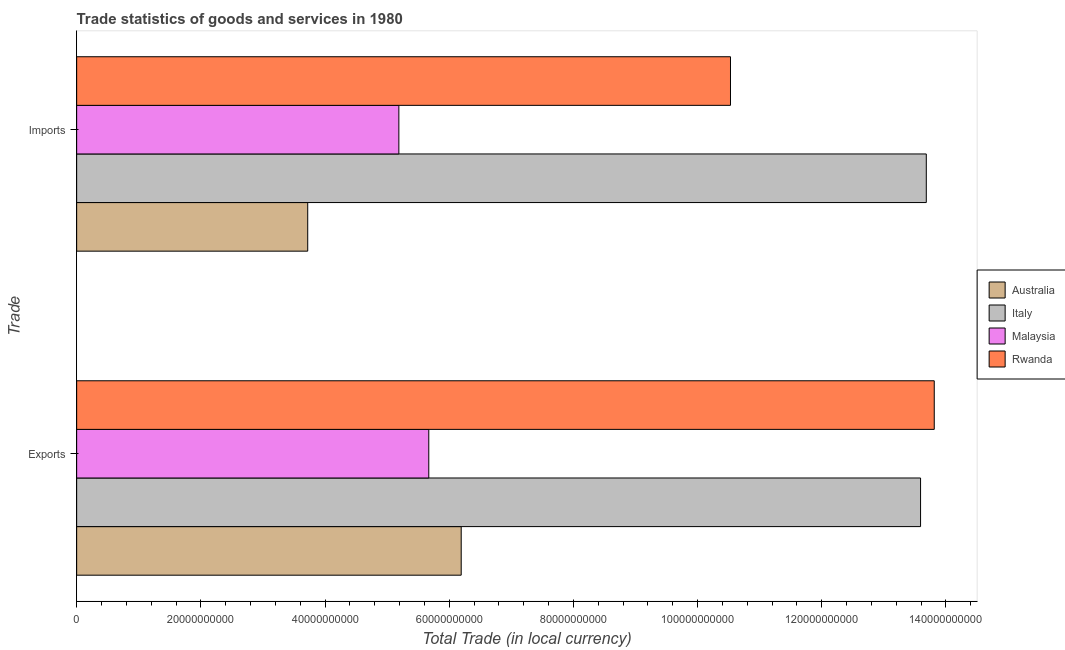How many different coloured bars are there?
Provide a short and direct response. 4. How many groups of bars are there?
Keep it short and to the point. 2. Are the number of bars per tick equal to the number of legend labels?
Offer a terse response. Yes. How many bars are there on the 1st tick from the top?
Keep it short and to the point. 4. How many bars are there on the 1st tick from the bottom?
Offer a terse response. 4. What is the label of the 2nd group of bars from the top?
Your response must be concise. Exports. What is the export of goods and services in Malaysia?
Give a very brief answer. 5.67e+1. Across all countries, what is the maximum imports of goods and services?
Your answer should be compact. 1.37e+11. Across all countries, what is the minimum export of goods and services?
Your answer should be compact. 5.67e+1. What is the total export of goods and services in the graph?
Give a very brief answer. 3.93e+11. What is the difference between the export of goods and services in Australia and that in Italy?
Ensure brevity in your answer.  -7.40e+1. What is the difference between the imports of goods and services in Australia and the export of goods and services in Malaysia?
Ensure brevity in your answer.  -1.95e+1. What is the average imports of goods and services per country?
Your response must be concise. 8.28e+1. What is the difference between the export of goods and services and imports of goods and services in Italy?
Keep it short and to the point. -9.24e+08. What is the ratio of the export of goods and services in Malaysia to that in Australia?
Offer a very short reply. 0.92. Is the export of goods and services in Australia less than that in Rwanda?
Keep it short and to the point. Yes. What does the 2nd bar from the top in Exports represents?
Your response must be concise. Malaysia. Are all the bars in the graph horizontal?
Offer a terse response. Yes. What is the difference between two consecutive major ticks on the X-axis?
Offer a very short reply. 2.00e+1. What is the title of the graph?
Your response must be concise. Trade statistics of goods and services in 1980. Does "Puerto Rico" appear as one of the legend labels in the graph?
Ensure brevity in your answer.  No. What is the label or title of the X-axis?
Provide a succinct answer. Total Trade (in local currency). What is the label or title of the Y-axis?
Your response must be concise. Trade. What is the Total Trade (in local currency) in Australia in Exports?
Give a very brief answer. 6.19e+1. What is the Total Trade (in local currency) in Italy in Exports?
Provide a succinct answer. 1.36e+11. What is the Total Trade (in local currency) of Malaysia in Exports?
Offer a terse response. 5.67e+1. What is the Total Trade (in local currency) in Rwanda in Exports?
Ensure brevity in your answer.  1.38e+11. What is the Total Trade (in local currency) in Australia in Imports?
Your answer should be compact. 3.72e+1. What is the Total Trade (in local currency) in Italy in Imports?
Your response must be concise. 1.37e+11. What is the Total Trade (in local currency) in Malaysia in Imports?
Your response must be concise. 5.19e+1. What is the Total Trade (in local currency) of Rwanda in Imports?
Provide a short and direct response. 1.05e+11. Across all Trade, what is the maximum Total Trade (in local currency) of Australia?
Provide a succinct answer. 6.19e+1. Across all Trade, what is the maximum Total Trade (in local currency) of Italy?
Your response must be concise. 1.37e+11. Across all Trade, what is the maximum Total Trade (in local currency) of Malaysia?
Provide a short and direct response. 5.67e+1. Across all Trade, what is the maximum Total Trade (in local currency) in Rwanda?
Make the answer very short. 1.38e+11. Across all Trade, what is the minimum Total Trade (in local currency) in Australia?
Your response must be concise. 3.72e+1. Across all Trade, what is the minimum Total Trade (in local currency) in Italy?
Your answer should be very brief. 1.36e+11. Across all Trade, what is the minimum Total Trade (in local currency) in Malaysia?
Your answer should be very brief. 5.19e+1. Across all Trade, what is the minimum Total Trade (in local currency) of Rwanda?
Give a very brief answer. 1.05e+11. What is the total Total Trade (in local currency) in Australia in the graph?
Offer a very short reply. 9.92e+1. What is the total Total Trade (in local currency) in Italy in the graph?
Your answer should be very brief. 2.73e+11. What is the total Total Trade (in local currency) in Malaysia in the graph?
Your answer should be very brief. 1.09e+11. What is the total Total Trade (in local currency) in Rwanda in the graph?
Ensure brevity in your answer.  2.43e+11. What is the difference between the Total Trade (in local currency) in Australia in Exports and that in Imports?
Keep it short and to the point. 2.47e+1. What is the difference between the Total Trade (in local currency) of Italy in Exports and that in Imports?
Provide a short and direct response. -9.24e+08. What is the difference between the Total Trade (in local currency) in Malaysia in Exports and that in Imports?
Give a very brief answer. 4.82e+09. What is the difference between the Total Trade (in local currency) in Rwanda in Exports and that in Imports?
Provide a succinct answer. 3.28e+1. What is the difference between the Total Trade (in local currency) in Australia in Exports and the Total Trade (in local currency) in Italy in Imports?
Keep it short and to the point. -7.49e+1. What is the difference between the Total Trade (in local currency) of Australia in Exports and the Total Trade (in local currency) of Malaysia in Imports?
Give a very brief answer. 1.00e+1. What is the difference between the Total Trade (in local currency) in Australia in Exports and the Total Trade (in local currency) in Rwanda in Imports?
Give a very brief answer. -4.34e+1. What is the difference between the Total Trade (in local currency) in Italy in Exports and the Total Trade (in local currency) in Malaysia in Imports?
Give a very brief answer. 8.40e+1. What is the difference between the Total Trade (in local currency) of Italy in Exports and the Total Trade (in local currency) of Rwanda in Imports?
Your answer should be compact. 3.06e+1. What is the difference between the Total Trade (in local currency) of Malaysia in Exports and the Total Trade (in local currency) of Rwanda in Imports?
Make the answer very short. -4.86e+1. What is the average Total Trade (in local currency) of Australia per Trade?
Your response must be concise. 4.96e+1. What is the average Total Trade (in local currency) in Italy per Trade?
Give a very brief answer. 1.36e+11. What is the average Total Trade (in local currency) in Malaysia per Trade?
Ensure brevity in your answer.  5.43e+1. What is the average Total Trade (in local currency) in Rwanda per Trade?
Provide a succinct answer. 1.22e+11. What is the difference between the Total Trade (in local currency) of Australia and Total Trade (in local currency) of Italy in Exports?
Give a very brief answer. -7.40e+1. What is the difference between the Total Trade (in local currency) in Australia and Total Trade (in local currency) in Malaysia in Exports?
Your response must be concise. 5.22e+09. What is the difference between the Total Trade (in local currency) of Australia and Total Trade (in local currency) of Rwanda in Exports?
Your answer should be compact. -7.62e+1. What is the difference between the Total Trade (in local currency) of Italy and Total Trade (in local currency) of Malaysia in Exports?
Give a very brief answer. 7.92e+1. What is the difference between the Total Trade (in local currency) of Italy and Total Trade (in local currency) of Rwanda in Exports?
Offer a terse response. -2.20e+09. What is the difference between the Total Trade (in local currency) of Malaysia and Total Trade (in local currency) of Rwanda in Exports?
Provide a short and direct response. -8.14e+1. What is the difference between the Total Trade (in local currency) of Australia and Total Trade (in local currency) of Italy in Imports?
Your response must be concise. -9.96e+1. What is the difference between the Total Trade (in local currency) of Australia and Total Trade (in local currency) of Malaysia in Imports?
Offer a very short reply. -1.47e+1. What is the difference between the Total Trade (in local currency) in Australia and Total Trade (in local currency) in Rwanda in Imports?
Make the answer very short. -6.81e+1. What is the difference between the Total Trade (in local currency) of Italy and Total Trade (in local currency) of Malaysia in Imports?
Ensure brevity in your answer.  8.50e+1. What is the difference between the Total Trade (in local currency) of Italy and Total Trade (in local currency) of Rwanda in Imports?
Ensure brevity in your answer.  3.15e+1. What is the difference between the Total Trade (in local currency) in Malaysia and Total Trade (in local currency) in Rwanda in Imports?
Ensure brevity in your answer.  -5.34e+1. What is the ratio of the Total Trade (in local currency) of Australia in Exports to that in Imports?
Ensure brevity in your answer.  1.66. What is the ratio of the Total Trade (in local currency) in Malaysia in Exports to that in Imports?
Offer a very short reply. 1.09. What is the ratio of the Total Trade (in local currency) of Rwanda in Exports to that in Imports?
Your answer should be compact. 1.31. What is the difference between the highest and the second highest Total Trade (in local currency) in Australia?
Your response must be concise. 2.47e+1. What is the difference between the highest and the second highest Total Trade (in local currency) in Italy?
Offer a terse response. 9.24e+08. What is the difference between the highest and the second highest Total Trade (in local currency) in Malaysia?
Give a very brief answer. 4.82e+09. What is the difference between the highest and the second highest Total Trade (in local currency) in Rwanda?
Make the answer very short. 3.28e+1. What is the difference between the highest and the lowest Total Trade (in local currency) of Australia?
Make the answer very short. 2.47e+1. What is the difference between the highest and the lowest Total Trade (in local currency) in Italy?
Offer a very short reply. 9.24e+08. What is the difference between the highest and the lowest Total Trade (in local currency) in Malaysia?
Provide a short and direct response. 4.82e+09. What is the difference between the highest and the lowest Total Trade (in local currency) of Rwanda?
Provide a succinct answer. 3.28e+1. 